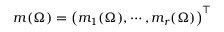Convert formula to latex. <formula><loc_0><loc_0><loc_500><loc_500>m ( \Omega ) = \left ( m _ { 1 } ( \Omega ) , \cdots , m _ { r } ( \Omega ) \right ) ^ { \top }</formula> 